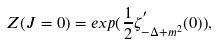Convert formula to latex. <formula><loc_0><loc_0><loc_500><loc_500>Z ( J = 0 ) = e x p { ( \frac { 1 } { 2 } \zeta ^ { ^ { \prime } } _ { - \Delta + m ^ { 2 } } ( 0 ) ) } ,</formula> 